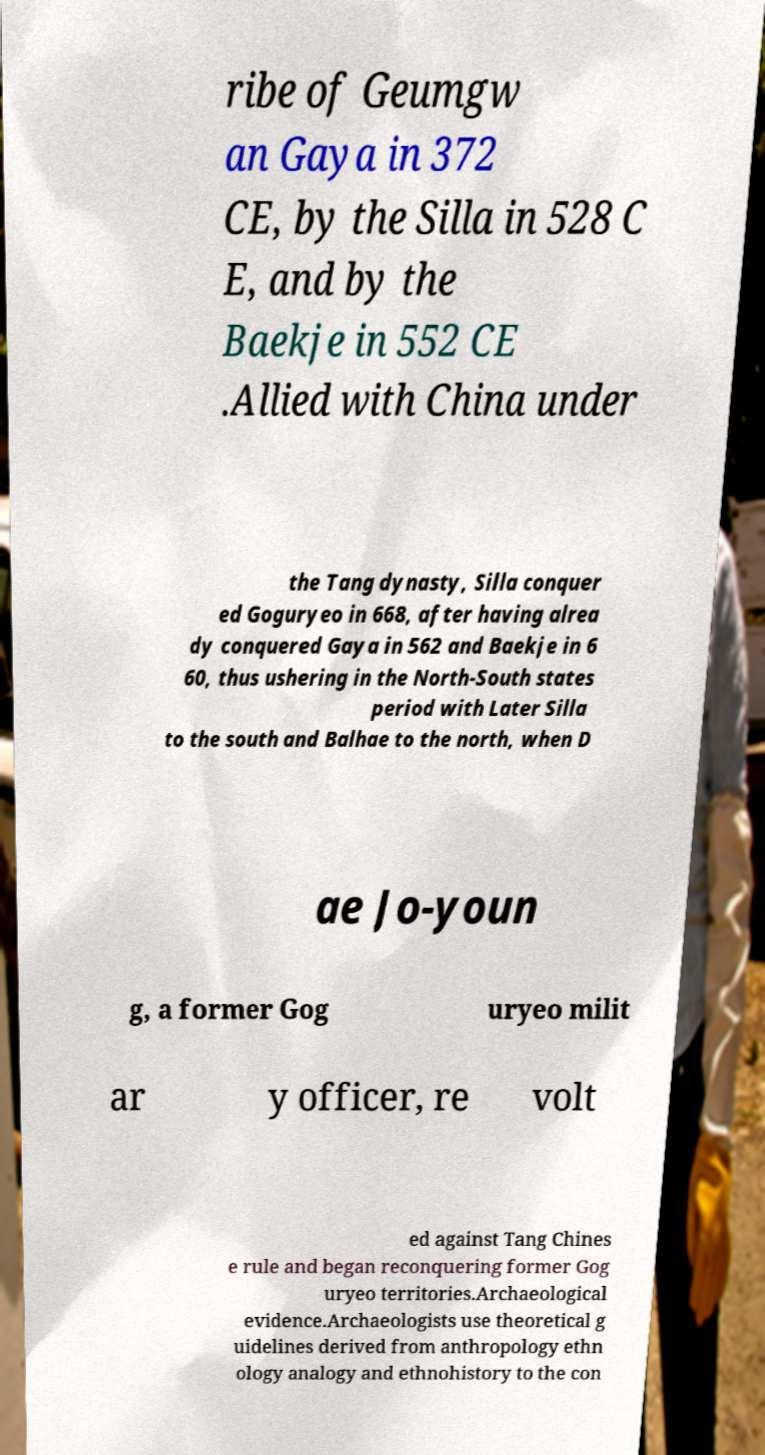Please identify and transcribe the text found in this image. ribe of Geumgw an Gaya in 372 CE, by the Silla in 528 C E, and by the Baekje in 552 CE .Allied with China under the Tang dynasty, Silla conquer ed Goguryeo in 668, after having alrea dy conquered Gaya in 562 and Baekje in 6 60, thus ushering in the North-South states period with Later Silla to the south and Balhae to the north, when D ae Jo-youn g, a former Gog uryeo milit ar y officer, re volt ed against Tang Chines e rule and began reconquering former Gog uryeo territories.Archaeological evidence.Archaeologists use theoretical g uidelines derived from anthropology ethn ology analogy and ethnohistory to the con 